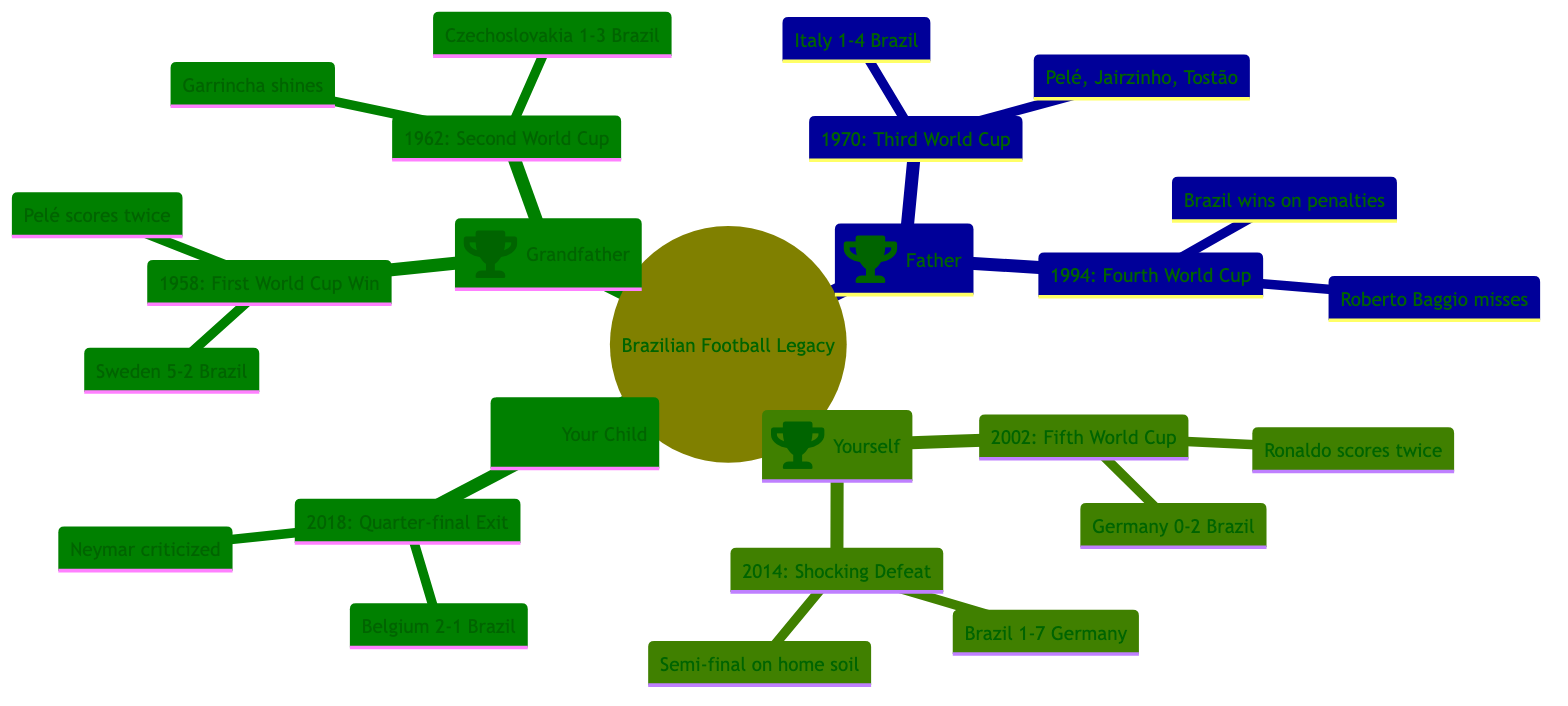What significant event took place in 1962? In the diagram, for the "Grandfather" generation, under the year 1962, it states that Brazil secured its second consecutive World Cup title by defeating Czechoslovakia 3-1 in Chile and highlights Garrincha's performance in Pelé's absence.
Answer: Brazil secures its second consecutive World Cup title What team did Brazil defeat in the 1970 World Cup final? Looking at the "Father" generation for the year 1970, the diagram shows that Brazil defeated Italy 4-1 in the World Cup final held in Mexico.
Answer: Italy How many World Cups did Brazil win during the times of the Grandfather and Father? In the "Grandfather" and "Father" generations, under significant moments, Brazil won four World Cups: two in the Grandfather's generation (1958, 1962) and two in the Father's generation (1970, 1994), totaling four.
Answer: Four What was the outcome of the 2014 World Cup semi-final for Brazil? In the "Yourself" generation, the 2014 event mentions that Brazil suffered a humiliating 7-1 defeat to Germany in the semi-final on home soil, which is a pivotal moment noted in the diagram.
Answer: Humiliating defeat What criticism did Neymar face during the 2018 World Cup? In the "Your Child" generation, the significant moment for 2018 states that Neymar's performance was criticized amid accusations of play-acting during the quarter-final loss to Belgium.
Answer: Criticized for play-acting Which significant moment happened in the year 2002? Referring to the "Yourself" generation in the year 2002, the diagram records Brazil winning its fifth World Cup in South Korea and Japan, beating Germany 2-0, with Ronaldo scoring twice.
Answer: Brazil wins its fifth World Cup How many significant moments are listed for Your Child? By examining the "Your Child" generation, it is noted that there is only one significant moment listed, which is the quarter-final exit in the 2018 World Cup.
Answer: One Which player is mentioned as shining in the 1962 World Cup? According to the "Grandfather" generation in 1962, the diagram highlights that Garrincha shined during Brazil's second consecutive World Cup win.
Answer: Garrincha What was the context of the final match in 1994? In the "Father" generation for the year 1994, it describes that the match against Italy was decided by a penalty shootout, with Roberto Baggio missing the decisive kick, marking a significant moment in that World Cup.
Answer: Penalty shootout 